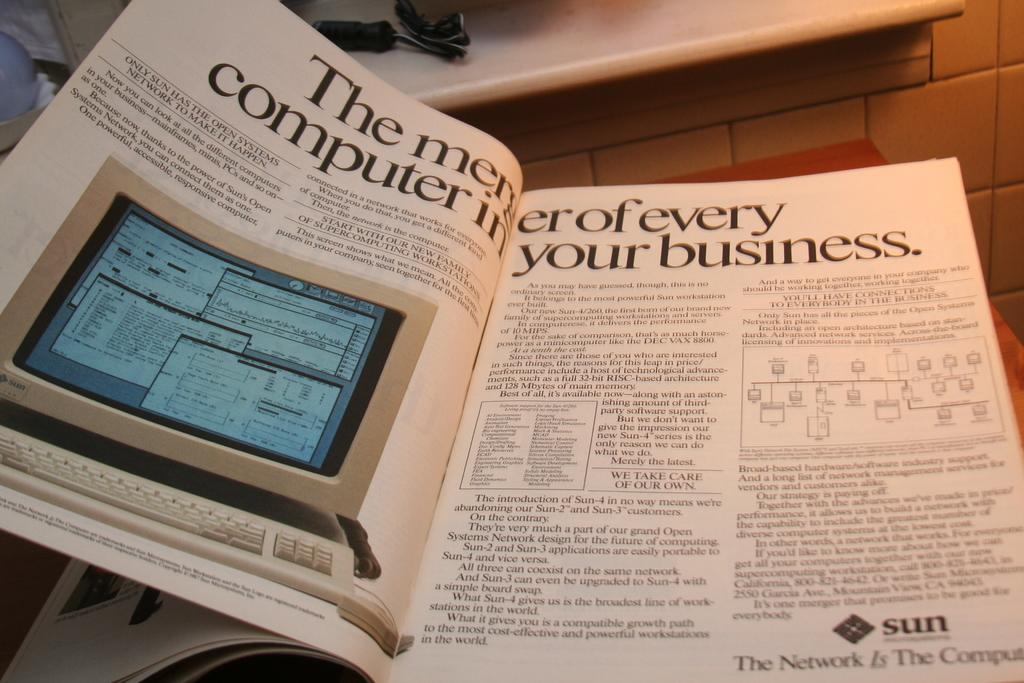What is present on the table in the image? There is a book on the table in the image. What can be found inside the book? The book contains text. Is there any illustration in the book? Yes, the book has a picture of a computer. What can be seen in the background of the image? There is a wall in the background of the image. What type of skin is visible on the computer in the image? There is no skin visible in the image, as it features a book with a picture of a computer, not an actual computer. 